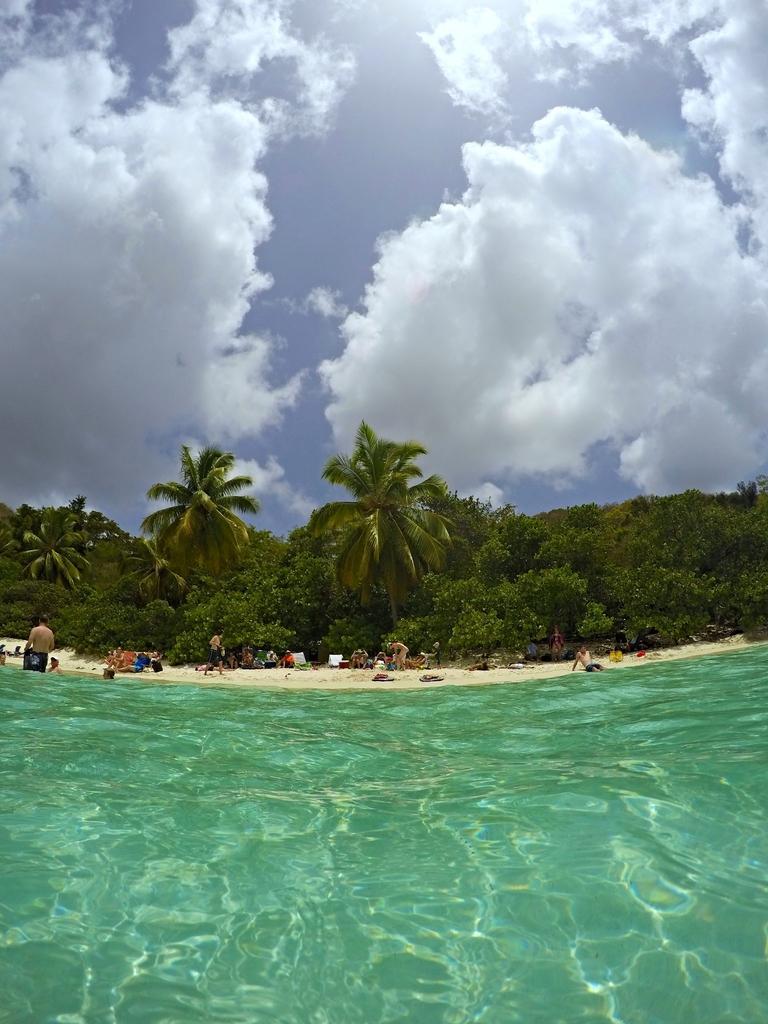In one or two sentences, can you explain what this image depicts? There is water. In the background there are many people, trees and sky with clouds. 